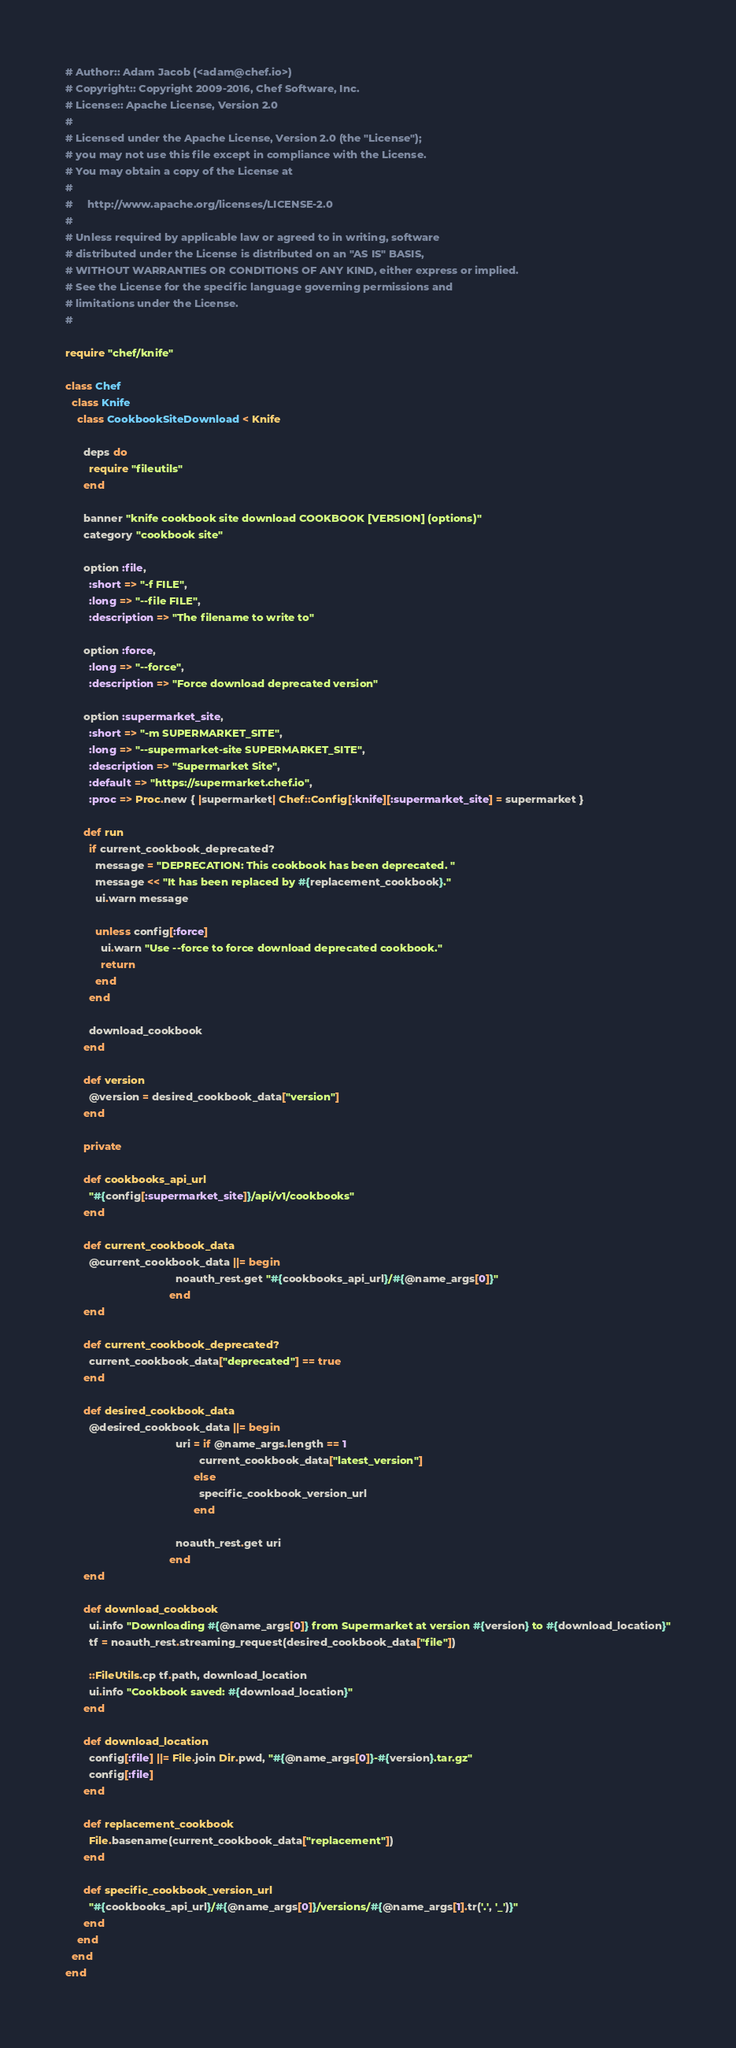<code> <loc_0><loc_0><loc_500><loc_500><_Ruby_># Author:: Adam Jacob (<adam@chef.io>)
# Copyright:: Copyright 2009-2016, Chef Software, Inc.
# License:: Apache License, Version 2.0
#
# Licensed under the Apache License, Version 2.0 (the "License");
# you may not use this file except in compliance with the License.
# You may obtain a copy of the License at
#
#     http://www.apache.org/licenses/LICENSE-2.0
#
# Unless required by applicable law or agreed to in writing, software
# distributed under the License is distributed on an "AS IS" BASIS,
# WITHOUT WARRANTIES OR CONDITIONS OF ANY KIND, either express or implied.
# See the License for the specific language governing permissions and
# limitations under the License.
#

require "chef/knife"

class Chef
  class Knife
    class CookbookSiteDownload < Knife

      deps do
        require "fileutils"
      end

      banner "knife cookbook site download COOKBOOK [VERSION] (options)"
      category "cookbook site"

      option :file,
        :short => "-f FILE",
        :long => "--file FILE",
        :description => "The filename to write to"

      option :force,
        :long => "--force",
        :description => "Force download deprecated version"

      option :supermarket_site,
        :short => "-m SUPERMARKET_SITE",
        :long => "--supermarket-site SUPERMARKET_SITE",
        :description => "Supermarket Site",
        :default => "https://supermarket.chef.io",
        :proc => Proc.new { |supermarket| Chef::Config[:knife][:supermarket_site] = supermarket }

      def run
        if current_cookbook_deprecated?
          message = "DEPRECATION: This cookbook has been deprecated. "
          message << "It has been replaced by #{replacement_cookbook}."
          ui.warn message

          unless config[:force]
            ui.warn "Use --force to force download deprecated cookbook."
            return
          end
        end

        download_cookbook
      end

      def version
        @version = desired_cookbook_data["version"]
      end

      private

      def cookbooks_api_url
        "#{config[:supermarket_site]}/api/v1/cookbooks"
      end

      def current_cookbook_data
        @current_cookbook_data ||= begin
                                     noauth_rest.get "#{cookbooks_api_url}/#{@name_args[0]}"
                                   end
      end

      def current_cookbook_deprecated?
        current_cookbook_data["deprecated"] == true
      end

      def desired_cookbook_data
        @desired_cookbook_data ||= begin
                                     uri = if @name_args.length == 1
                                             current_cookbook_data["latest_version"]
                                           else
                                             specific_cookbook_version_url
                                           end

                                     noauth_rest.get uri
                                   end
      end

      def download_cookbook
        ui.info "Downloading #{@name_args[0]} from Supermarket at version #{version} to #{download_location}"
        tf = noauth_rest.streaming_request(desired_cookbook_data["file"])

        ::FileUtils.cp tf.path, download_location
        ui.info "Cookbook saved: #{download_location}"
      end

      def download_location
        config[:file] ||= File.join Dir.pwd, "#{@name_args[0]}-#{version}.tar.gz"
        config[:file]
      end

      def replacement_cookbook
        File.basename(current_cookbook_data["replacement"])
      end

      def specific_cookbook_version_url
        "#{cookbooks_api_url}/#{@name_args[0]}/versions/#{@name_args[1].tr('.', '_')}"
      end
    end
  end
end
</code> 